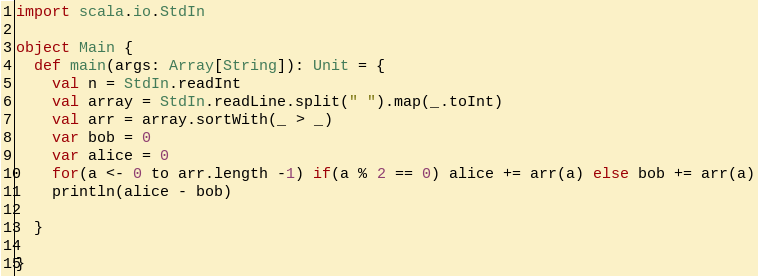Convert code to text. <code><loc_0><loc_0><loc_500><loc_500><_Scala_>import scala.io.StdIn

object Main {
  def main(args: Array[String]): Unit = {
    val n = StdIn.readInt
    val array = StdIn.readLine.split(" ").map(_.toInt)
    val arr = array.sortWith(_ > _)
    var bob = 0
    var alice = 0
    for(a <- 0 to arr.length -1) if(a % 2 == 0) alice += arr(a) else bob += arr(a)
    println(alice - bob)
    
  }
  
}</code> 